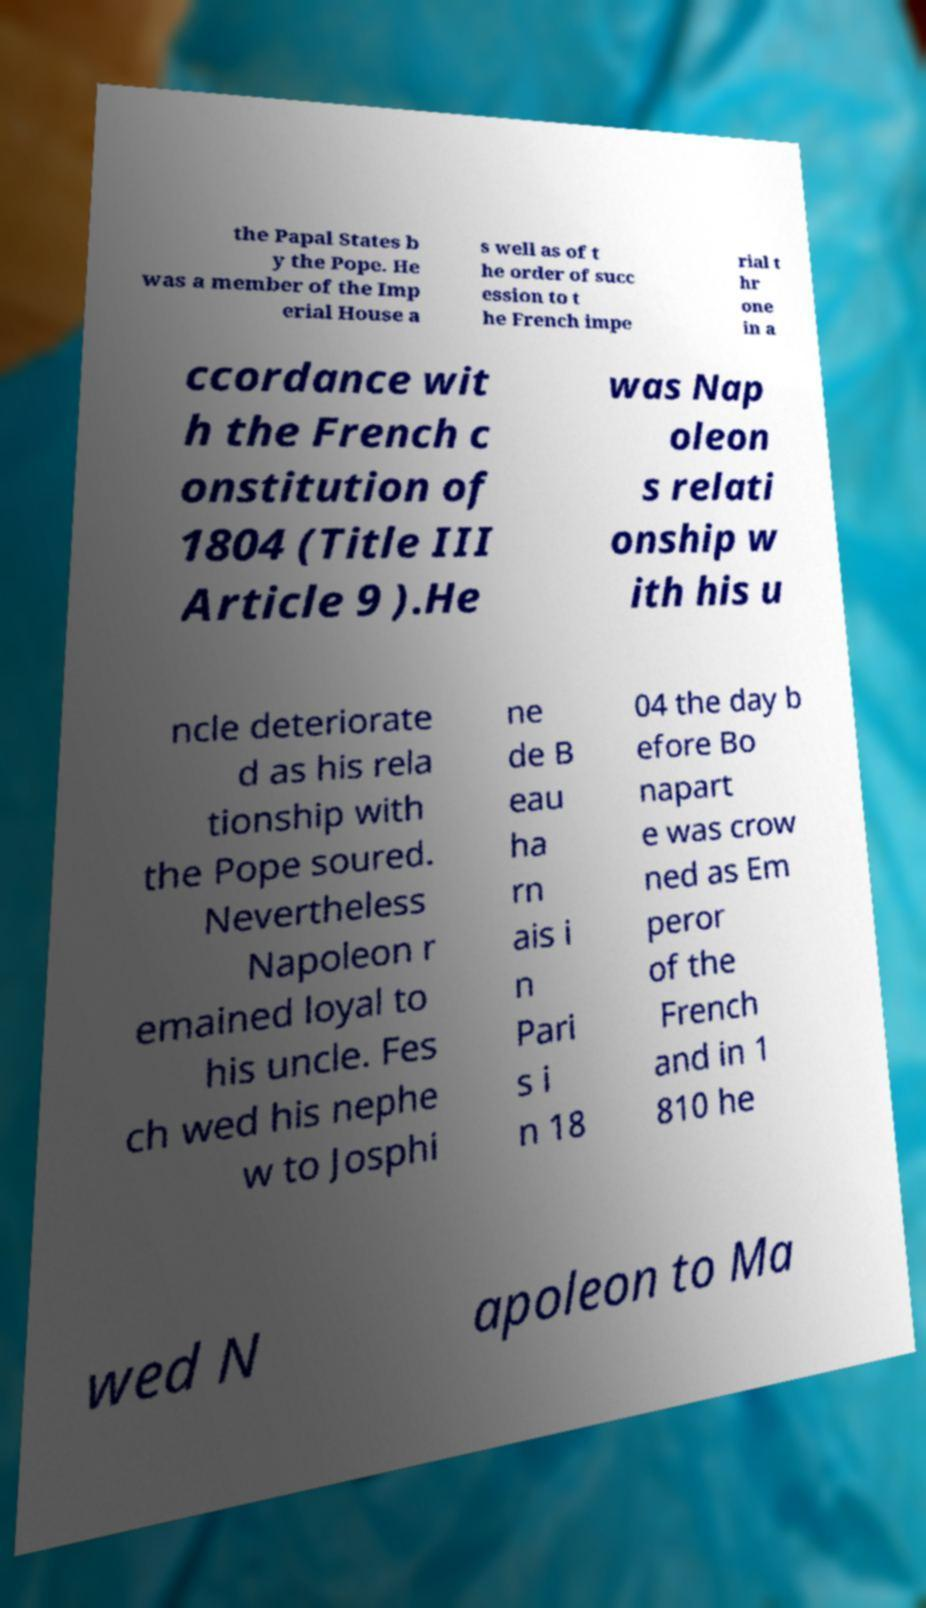Can you read and provide the text displayed in the image?This photo seems to have some interesting text. Can you extract and type it out for me? the Papal States b y the Pope. He was a member of the Imp erial House a s well as of t he order of succ ession to t he French impe rial t hr one in a ccordance wit h the French c onstitution of 1804 (Title III Article 9 ).He was Nap oleon s relati onship w ith his u ncle deteriorate d as his rela tionship with the Pope soured. Nevertheless Napoleon r emained loyal to his uncle. Fes ch wed his nephe w to Josphi ne de B eau ha rn ais i n Pari s i n 18 04 the day b efore Bo napart e was crow ned as Em peror of the French and in 1 810 he wed N apoleon to Ma 